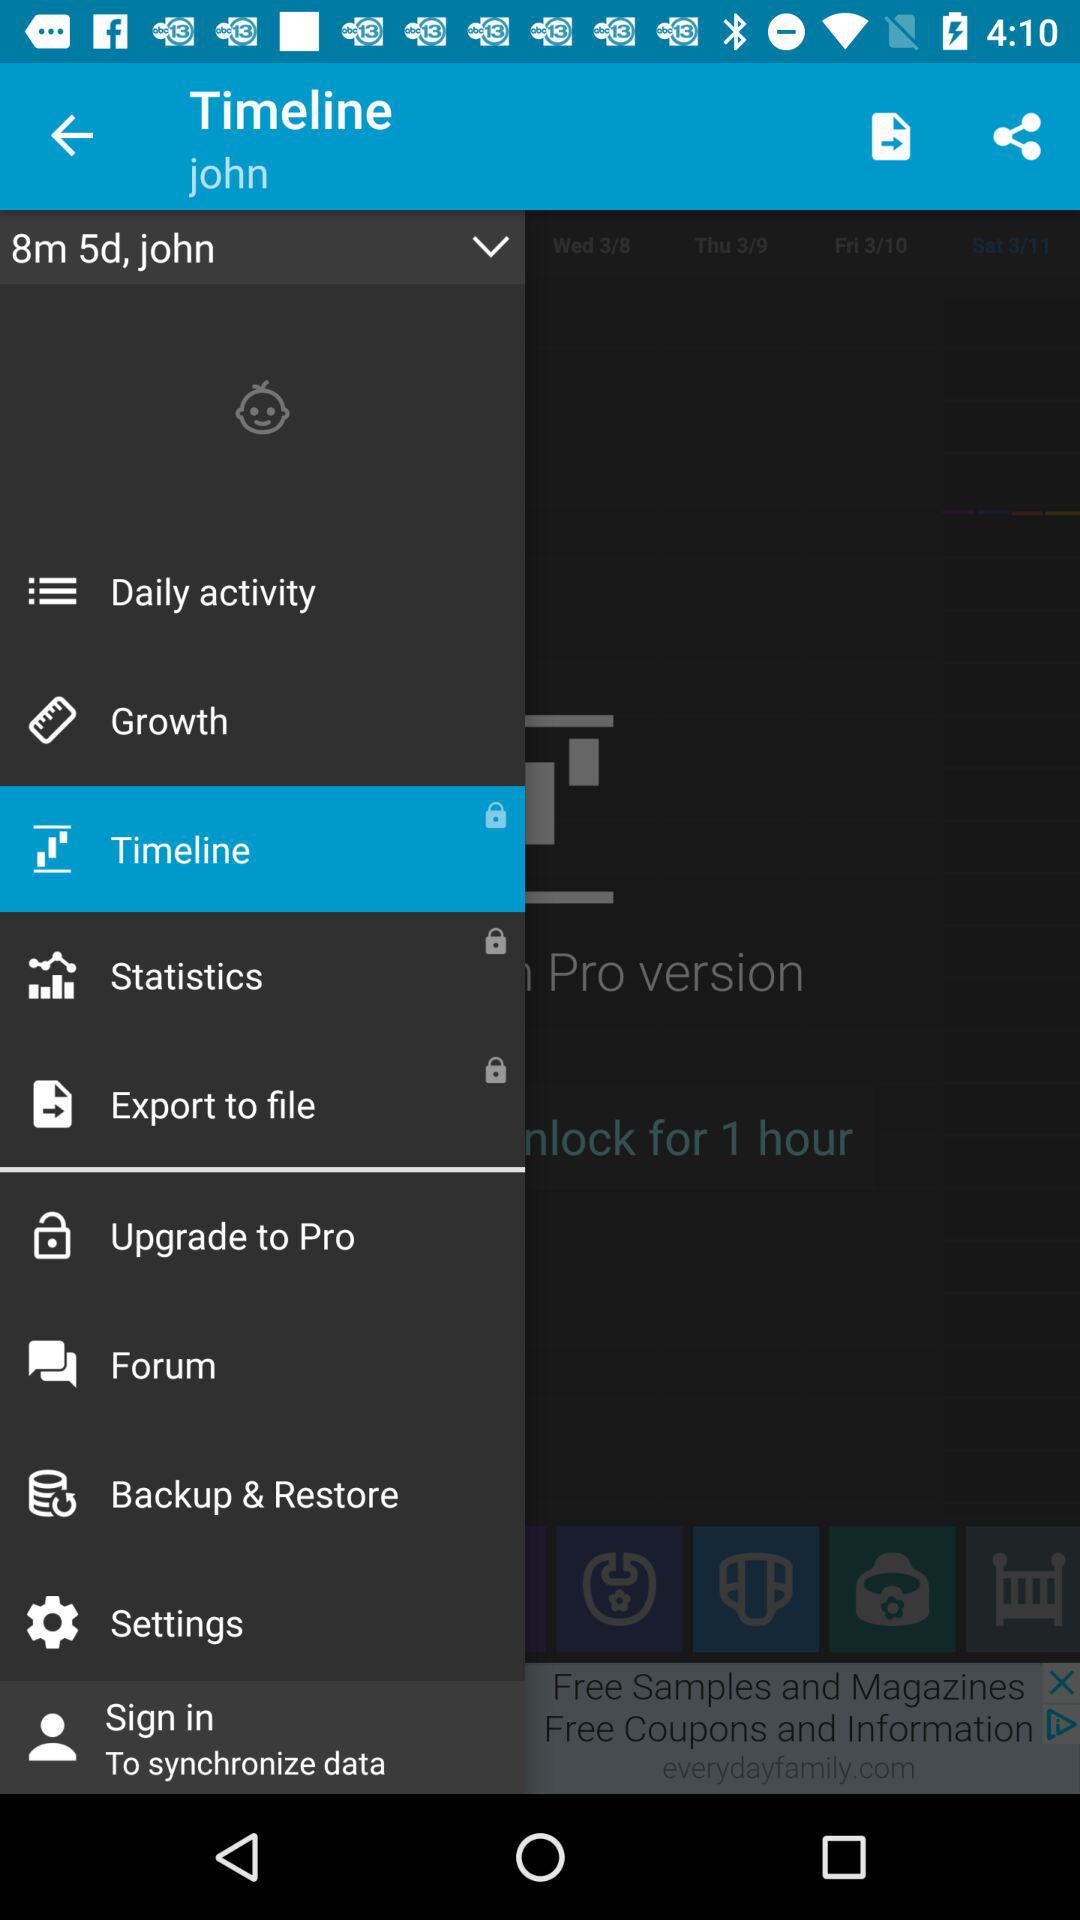How many days are there in the timeline?
Answer the question using a single word or phrase. 4 